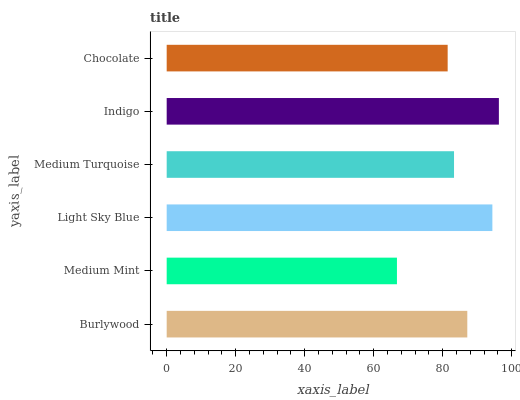Is Medium Mint the minimum?
Answer yes or no. Yes. Is Indigo the maximum?
Answer yes or no. Yes. Is Light Sky Blue the minimum?
Answer yes or no. No. Is Light Sky Blue the maximum?
Answer yes or no. No. Is Light Sky Blue greater than Medium Mint?
Answer yes or no. Yes. Is Medium Mint less than Light Sky Blue?
Answer yes or no. Yes. Is Medium Mint greater than Light Sky Blue?
Answer yes or no. No. Is Light Sky Blue less than Medium Mint?
Answer yes or no. No. Is Burlywood the high median?
Answer yes or no. Yes. Is Medium Turquoise the low median?
Answer yes or no. Yes. Is Medium Turquoise the high median?
Answer yes or no. No. Is Chocolate the low median?
Answer yes or no. No. 